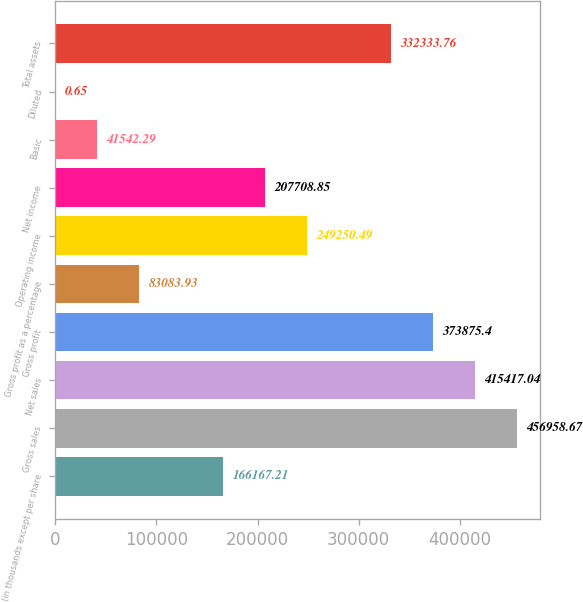<chart> <loc_0><loc_0><loc_500><loc_500><bar_chart><fcel>(in thousands except per share<fcel>Gross sales<fcel>Net sales<fcel>Gross profit<fcel>Gross profit as a percentage<fcel>Operating income<fcel>Net income<fcel>Basic<fcel>Diluted<fcel>Total assets<nl><fcel>166167<fcel>456959<fcel>415417<fcel>373875<fcel>83083.9<fcel>249250<fcel>207709<fcel>41542.3<fcel>0.65<fcel>332334<nl></chart> 